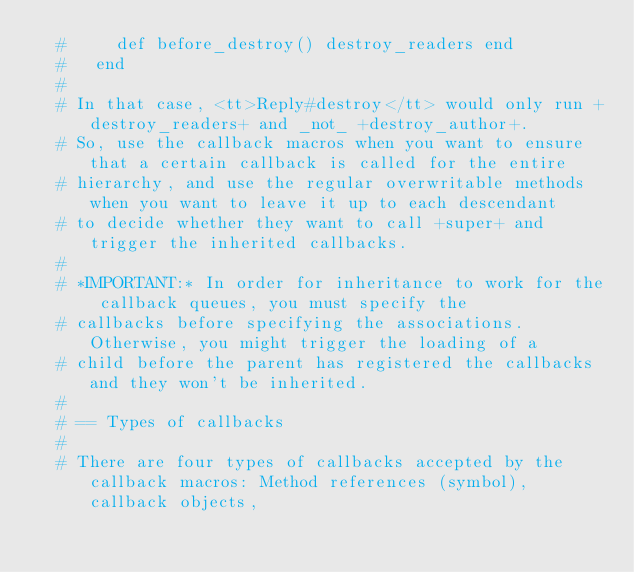<code> <loc_0><loc_0><loc_500><loc_500><_Ruby_>  #     def before_destroy() destroy_readers end
  #   end
  #
  # In that case, <tt>Reply#destroy</tt> would only run +destroy_readers+ and _not_ +destroy_author+.
  # So, use the callback macros when you want to ensure that a certain callback is called for the entire
  # hierarchy, and use the regular overwritable methods when you want to leave it up to each descendant
  # to decide whether they want to call +super+ and trigger the inherited callbacks.
  #
  # *IMPORTANT:* In order for inheritance to work for the callback queues, you must specify the
  # callbacks before specifying the associations. Otherwise, you might trigger the loading of a
  # child before the parent has registered the callbacks and they won't be inherited.
  #
  # == Types of callbacks
  #
  # There are four types of callbacks accepted by the callback macros: Method references (symbol), callback objects,</code> 